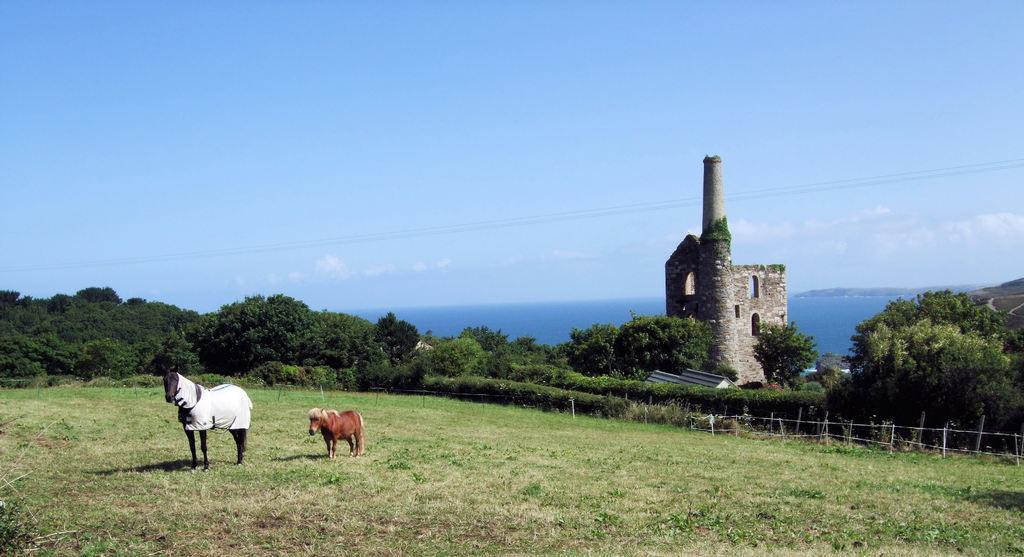How would you summarize this image in a sentence or two? In the image we can see there are two horses standing on the ground and the ground is covered with grass. Behind there are lot of trees and there is a building at the back. 